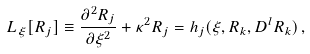Convert formula to latex. <formula><loc_0><loc_0><loc_500><loc_500>L _ { \xi } [ R _ { j } ] \equiv \frac { \partial ^ { 2 } R _ { j } } { \partial \xi ^ { 2 } } + \kappa ^ { 2 } R _ { j } = h _ { j } ( \xi , R _ { k } , D ^ { l } R _ { k } ) \, ,</formula> 